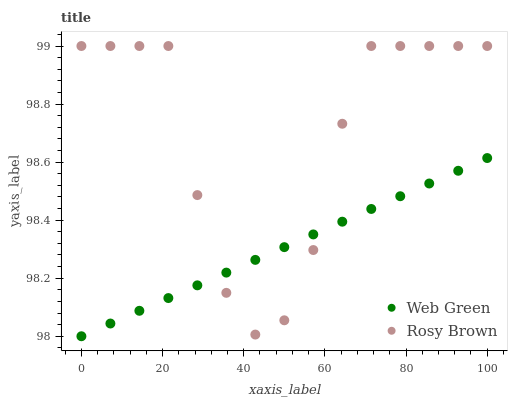Does Web Green have the minimum area under the curve?
Answer yes or no. Yes. Does Rosy Brown have the maximum area under the curve?
Answer yes or no. Yes. Does Web Green have the maximum area under the curve?
Answer yes or no. No. Is Web Green the smoothest?
Answer yes or no. Yes. Is Rosy Brown the roughest?
Answer yes or no. Yes. Is Web Green the roughest?
Answer yes or no. No. Does Web Green have the lowest value?
Answer yes or no. Yes. Does Rosy Brown have the highest value?
Answer yes or no. Yes. Does Web Green have the highest value?
Answer yes or no. No. Does Web Green intersect Rosy Brown?
Answer yes or no. Yes. Is Web Green less than Rosy Brown?
Answer yes or no. No. Is Web Green greater than Rosy Brown?
Answer yes or no. No. 